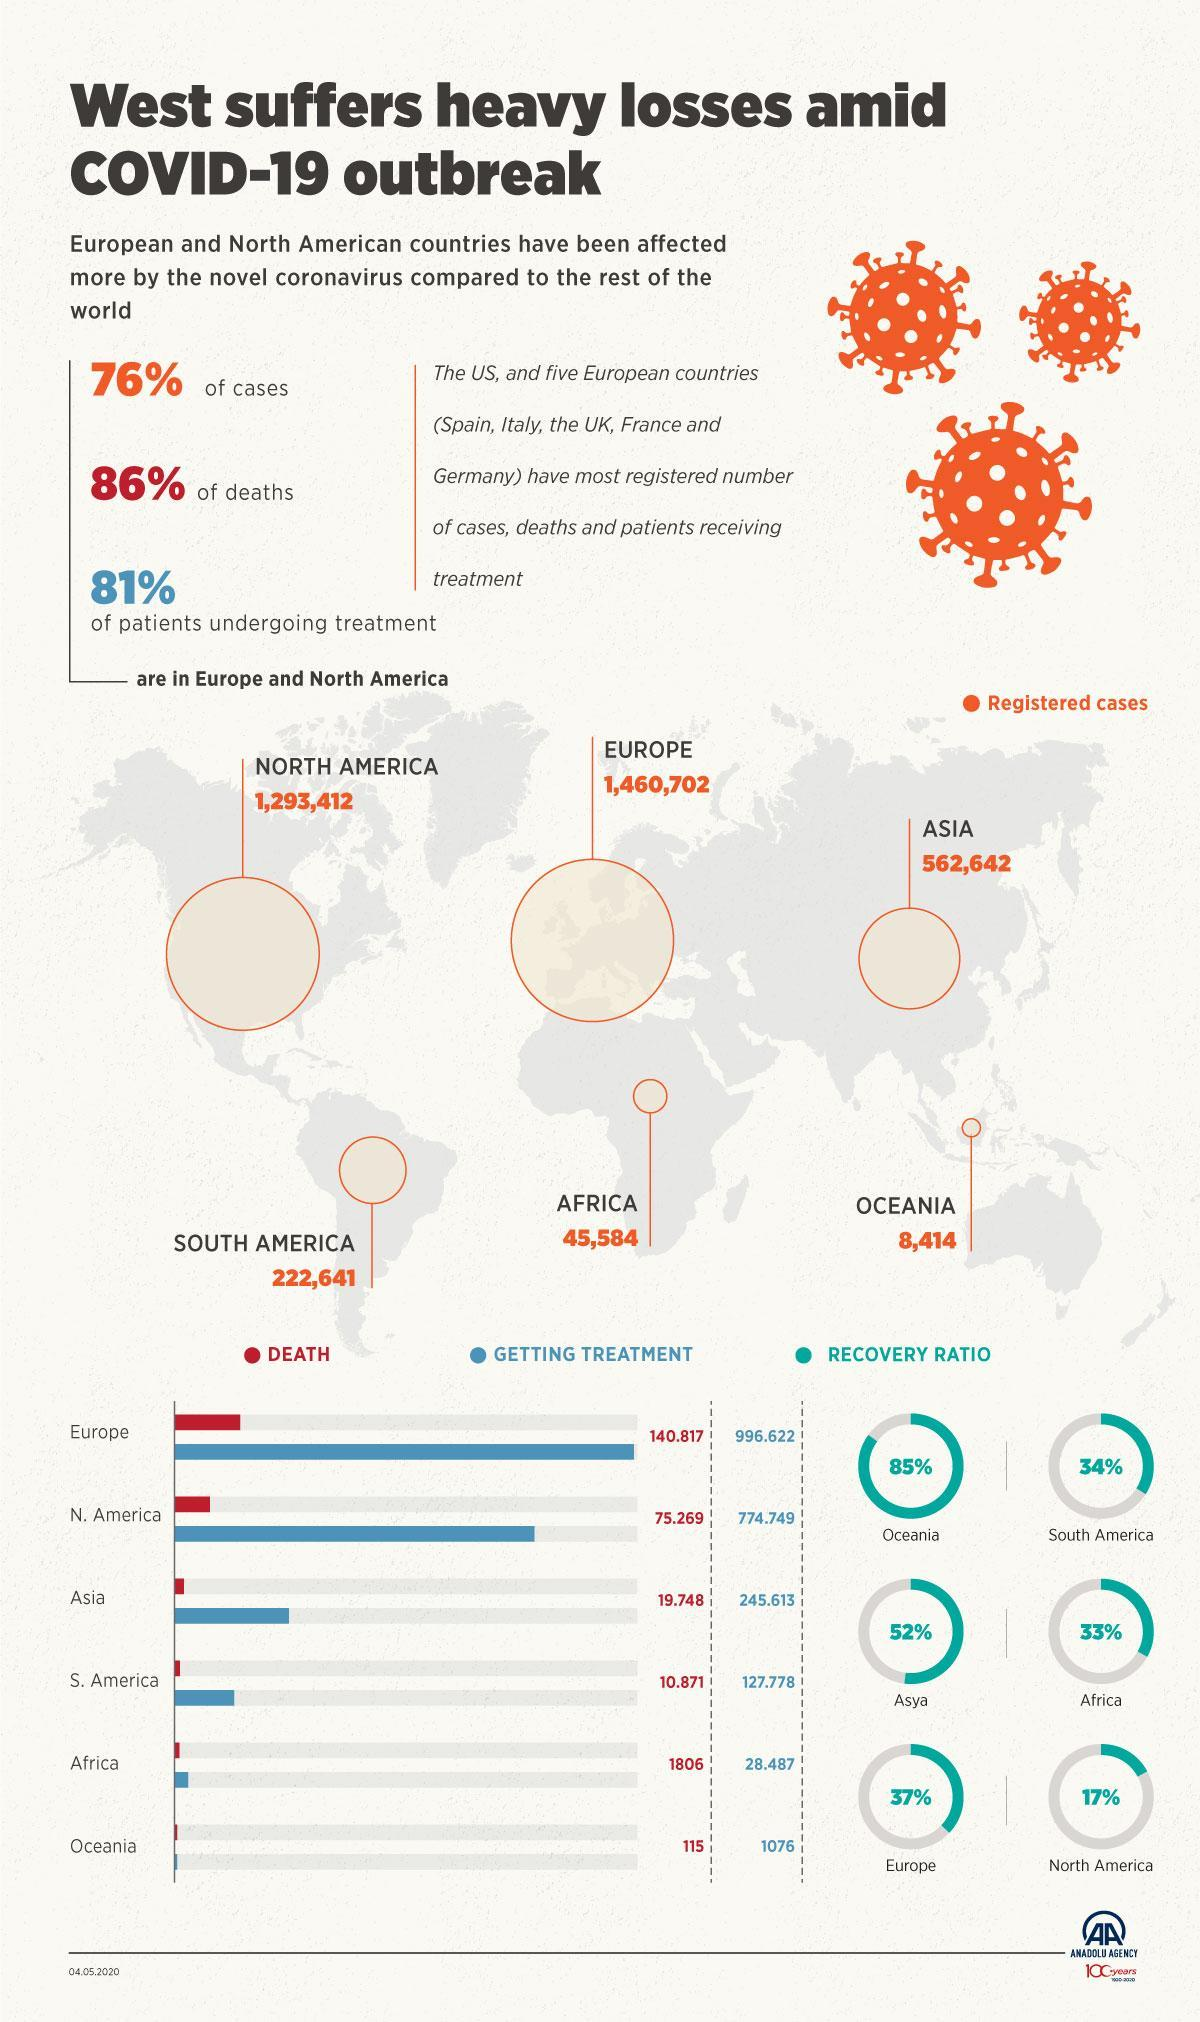How many continents show recovery ratio above 50%?
Answer the question with a short phrase. 2 Which continent has more registered cases - Africa or Asia? Asia Which continent has a recovery ratio of 17%? North America What percentage of total covid-19 deaths reported are in Europe and North America? 86% As per the graph, which continent has more deaths reported - Europe, Africa or Asia? Europe Which continent has above 1.4 million registered cases? Europe Which continent has less than 10,000 registered covid-19 cases? Oceania What is the recovery ratio for South America? 34% In which continents are 76% of Covid -19 cases reported? Europe and North America 